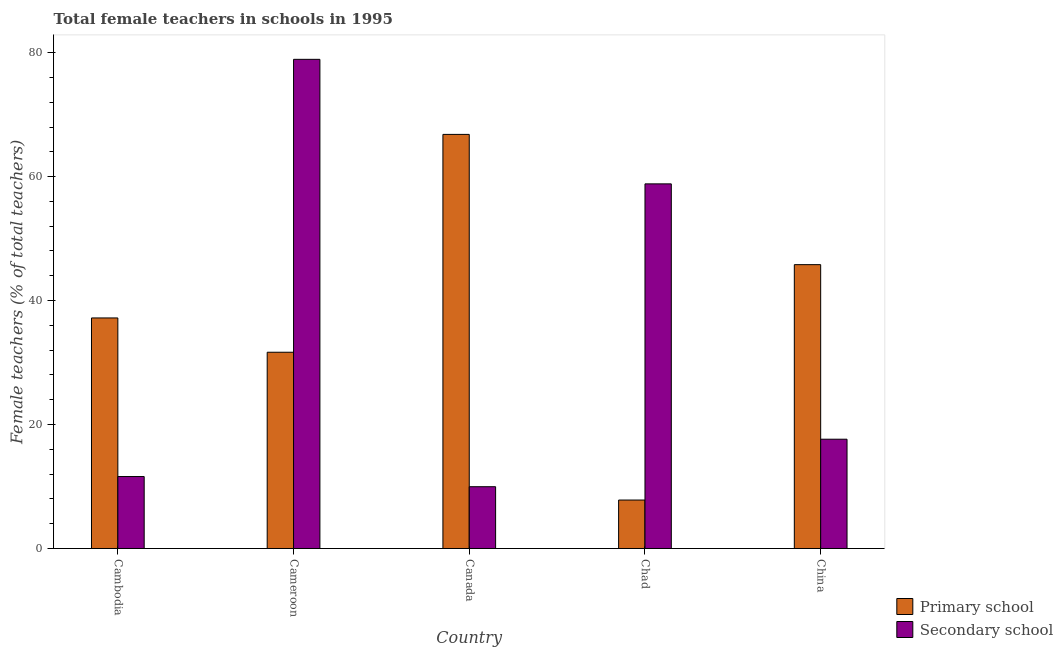How many groups of bars are there?
Offer a very short reply. 5. Are the number of bars per tick equal to the number of legend labels?
Offer a very short reply. Yes. Are the number of bars on each tick of the X-axis equal?
Make the answer very short. Yes. What is the label of the 3rd group of bars from the left?
Offer a terse response. Canada. What is the percentage of female teachers in primary schools in China?
Keep it short and to the point. 45.8. Across all countries, what is the maximum percentage of female teachers in primary schools?
Provide a short and direct response. 66.81. Across all countries, what is the minimum percentage of female teachers in secondary schools?
Make the answer very short. 9.97. In which country was the percentage of female teachers in secondary schools maximum?
Ensure brevity in your answer.  Cameroon. In which country was the percentage of female teachers in primary schools minimum?
Your answer should be compact. Chad. What is the total percentage of female teachers in secondary schools in the graph?
Make the answer very short. 176.97. What is the difference between the percentage of female teachers in primary schools in Cameroon and that in Canada?
Offer a very short reply. -35.15. What is the difference between the percentage of female teachers in secondary schools in China and the percentage of female teachers in primary schools in Cameroon?
Your response must be concise. -14.03. What is the average percentage of female teachers in primary schools per country?
Your response must be concise. 37.86. What is the difference between the percentage of female teachers in primary schools and percentage of female teachers in secondary schools in China?
Make the answer very short. 28.16. What is the ratio of the percentage of female teachers in secondary schools in Canada to that in Chad?
Your answer should be very brief. 0.17. Is the difference between the percentage of female teachers in secondary schools in Canada and China greater than the difference between the percentage of female teachers in primary schools in Canada and China?
Provide a short and direct response. No. What is the difference between the highest and the second highest percentage of female teachers in secondary schools?
Make the answer very short. 20.09. What is the difference between the highest and the lowest percentage of female teachers in primary schools?
Keep it short and to the point. 59. Is the sum of the percentage of female teachers in secondary schools in Cambodia and Canada greater than the maximum percentage of female teachers in primary schools across all countries?
Ensure brevity in your answer.  No. What does the 2nd bar from the left in Cameroon represents?
Provide a short and direct response. Secondary school. What does the 2nd bar from the right in Cambodia represents?
Your answer should be very brief. Primary school. How many bars are there?
Keep it short and to the point. 10. Are the values on the major ticks of Y-axis written in scientific E-notation?
Keep it short and to the point. No. Does the graph contain any zero values?
Make the answer very short. No. Where does the legend appear in the graph?
Offer a very short reply. Bottom right. How many legend labels are there?
Provide a short and direct response. 2. How are the legend labels stacked?
Your response must be concise. Vertical. What is the title of the graph?
Provide a succinct answer. Total female teachers in schools in 1995. What is the label or title of the X-axis?
Provide a succinct answer. Country. What is the label or title of the Y-axis?
Offer a very short reply. Female teachers (% of total teachers). What is the Female teachers (% of total teachers) of Primary school in Cambodia?
Ensure brevity in your answer.  37.2. What is the Female teachers (% of total teachers) in Secondary school in Cambodia?
Offer a very short reply. 11.61. What is the Female teachers (% of total teachers) in Primary school in Cameroon?
Your answer should be very brief. 31.66. What is the Female teachers (% of total teachers) in Secondary school in Cameroon?
Offer a terse response. 78.93. What is the Female teachers (% of total teachers) in Primary school in Canada?
Make the answer very short. 66.81. What is the Female teachers (% of total teachers) of Secondary school in Canada?
Provide a succinct answer. 9.97. What is the Female teachers (% of total teachers) in Primary school in Chad?
Provide a short and direct response. 7.82. What is the Female teachers (% of total teachers) in Secondary school in Chad?
Offer a terse response. 58.83. What is the Female teachers (% of total teachers) in Primary school in China?
Provide a short and direct response. 45.8. What is the Female teachers (% of total teachers) in Secondary school in China?
Keep it short and to the point. 17.63. Across all countries, what is the maximum Female teachers (% of total teachers) of Primary school?
Provide a succinct answer. 66.81. Across all countries, what is the maximum Female teachers (% of total teachers) in Secondary school?
Offer a terse response. 78.93. Across all countries, what is the minimum Female teachers (% of total teachers) in Primary school?
Provide a succinct answer. 7.82. Across all countries, what is the minimum Female teachers (% of total teachers) of Secondary school?
Your answer should be compact. 9.97. What is the total Female teachers (% of total teachers) of Primary school in the graph?
Your answer should be compact. 189.29. What is the total Female teachers (% of total teachers) in Secondary school in the graph?
Ensure brevity in your answer.  176.97. What is the difference between the Female teachers (% of total teachers) in Primary school in Cambodia and that in Cameroon?
Give a very brief answer. 5.53. What is the difference between the Female teachers (% of total teachers) of Secondary school in Cambodia and that in Cameroon?
Provide a succinct answer. -67.32. What is the difference between the Female teachers (% of total teachers) in Primary school in Cambodia and that in Canada?
Keep it short and to the point. -29.62. What is the difference between the Female teachers (% of total teachers) in Secondary school in Cambodia and that in Canada?
Provide a short and direct response. 1.64. What is the difference between the Female teachers (% of total teachers) in Primary school in Cambodia and that in Chad?
Provide a succinct answer. 29.38. What is the difference between the Female teachers (% of total teachers) in Secondary school in Cambodia and that in Chad?
Offer a terse response. -47.22. What is the difference between the Female teachers (% of total teachers) of Primary school in Cambodia and that in China?
Make the answer very short. -8.6. What is the difference between the Female teachers (% of total teachers) in Secondary school in Cambodia and that in China?
Make the answer very short. -6.02. What is the difference between the Female teachers (% of total teachers) of Primary school in Cameroon and that in Canada?
Offer a terse response. -35.15. What is the difference between the Female teachers (% of total teachers) of Secondary school in Cameroon and that in Canada?
Offer a terse response. 68.96. What is the difference between the Female teachers (% of total teachers) in Primary school in Cameroon and that in Chad?
Provide a short and direct response. 23.85. What is the difference between the Female teachers (% of total teachers) in Secondary school in Cameroon and that in Chad?
Offer a very short reply. 20.09. What is the difference between the Female teachers (% of total teachers) in Primary school in Cameroon and that in China?
Offer a terse response. -14.13. What is the difference between the Female teachers (% of total teachers) in Secondary school in Cameroon and that in China?
Your answer should be compact. 61.29. What is the difference between the Female teachers (% of total teachers) of Primary school in Canada and that in Chad?
Keep it short and to the point. 59. What is the difference between the Female teachers (% of total teachers) of Secondary school in Canada and that in Chad?
Give a very brief answer. -48.86. What is the difference between the Female teachers (% of total teachers) in Primary school in Canada and that in China?
Give a very brief answer. 21.02. What is the difference between the Female teachers (% of total teachers) of Secondary school in Canada and that in China?
Provide a succinct answer. -7.66. What is the difference between the Female teachers (% of total teachers) of Primary school in Chad and that in China?
Offer a terse response. -37.98. What is the difference between the Female teachers (% of total teachers) of Secondary school in Chad and that in China?
Keep it short and to the point. 41.2. What is the difference between the Female teachers (% of total teachers) in Primary school in Cambodia and the Female teachers (% of total teachers) in Secondary school in Cameroon?
Keep it short and to the point. -41.73. What is the difference between the Female teachers (% of total teachers) in Primary school in Cambodia and the Female teachers (% of total teachers) in Secondary school in Canada?
Make the answer very short. 27.23. What is the difference between the Female teachers (% of total teachers) of Primary school in Cambodia and the Female teachers (% of total teachers) of Secondary school in Chad?
Provide a succinct answer. -21.63. What is the difference between the Female teachers (% of total teachers) of Primary school in Cambodia and the Female teachers (% of total teachers) of Secondary school in China?
Your answer should be compact. 19.57. What is the difference between the Female teachers (% of total teachers) in Primary school in Cameroon and the Female teachers (% of total teachers) in Secondary school in Canada?
Keep it short and to the point. 21.7. What is the difference between the Female teachers (% of total teachers) in Primary school in Cameroon and the Female teachers (% of total teachers) in Secondary school in Chad?
Your answer should be very brief. -27.17. What is the difference between the Female teachers (% of total teachers) in Primary school in Cameroon and the Female teachers (% of total teachers) in Secondary school in China?
Ensure brevity in your answer.  14.03. What is the difference between the Female teachers (% of total teachers) in Primary school in Canada and the Female teachers (% of total teachers) in Secondary school in Chad?
Give a very brief answer. 7.98. What is the difference between the Female teachers (% of total teachers) in Primary school in Canada and the Female teachers (% of total teachers) in Secondary school in China?
Give a very brief answer. 49.18. What is the difference between the Female teachers (% of total teachers) of Primary school in Chad and the Female teachers (% of total teachers) of Secondary school in China?
Offer a terse response. -9.81. What is the average Female teachers (% of total teachers) in Primary school per country?
Offer a very short reply. 37.86. What is the average Female teachers (% of total teachers) in Secondary school per country?
Provide a short and direct response. 35.39. What is the difference between the Female teachers (% of total teachers) in Primary school and Female teachers (% of total teachers) in Secondary school in Cambodia?
Your response must be concise. 25.59. What is the difference between the Female teachers (% of total teachers) in Primary school and Female teachers (% of total teachers) in Secondary school in Cameroon?
Offer a very short reply. -47.26. What is the difference between the Female teachers (% of total teachers) of Primary school and Female teachers (% of total teachers) of Secondary school in Canada?
Give a very brief answer. 56.85. What is the difference between the Female teachers (% of total teachers) in Primary school and Female teachers (% of total teachers) in Secondary school in Chad?
Provide a short and direct response. -51.01. What is the difference between the Female teachers (% of total teachers) of Primary school and Female teachers (% of total teachers) of Secondary school in China?
Offer a terse response. 28.16. What is the ratio of the Female teachers (% of total teachers) in Primary school in Cambodia to that in Cameroon?
Ensure brevity in your answer.  1.17. What is the ratio of the Female teachers (% of total teachers) of Secondary school in Cambodia to that in Cameroon?
Provide a succinct answer. 0.15. What is the ratio of the Female teachers (% of total teachers) in Primary school in Cambodia to that in Canada?
Your answer should be very brief. 0.56. What is the ratio of the Female teachers (% of total teachers) of Secondary school in Cambodia to that in Canada?
Give a very brief answer. 1.16. What is the ratio of the Female teachers (% of total teachers) in Primary school in Cambodia to that in Chad?
Provide a succinct answer. 4.76. What is the ratio of the Female teachers (% of total teachers) of Secondary school in Cambodia to that in Chad?
Give a very brief answer. 0.2. What is the ratio of the Female teachers (% of total teachers) in Primary school in Cambodia to that in China?
Give a very brief answer. 0.81. What is the ratio of the Female teachers (% of total teachers) of Secondary school in Cambodia to that in China?
Provide a succinct answer. 0.66. What is the ratio of the Female teachers (% of total teachers) in Primary school in Cameroon to that in Canada?
Keep it short and to the point. 0.47. What is the ratio of the Female teachers (% of total teachers) in Secondary school in Cameroon to that in Canada?
Give a very brief answer. 7.92. What is the ratio of the Female teachers (% of total teachers) of Primary school in Cameroon to that in Chad?
Your response must be concise. 4.05. What is the ratio of the Female teachers (% of total teachers) in Secondary school in Cameroon to that in Chad?
Provide a succinct answer. 1.34. What is the ratio of the Female teachers (% of total teachers) of Primary school in Cameroon to that in China?
Keep it short and to the point. 0.69. What is the ratio of the Female teachers (% of total teachers) of Secondary school in Cameroon to that in China?
Ensure brevity in your answer.  4.48. What is the ratio of the Female teachers (% of total teachers) in Primary school in Canada to that in Chad?
Provide a succinct answer. 8.55. What is the ratio of the Female teachers (% of total teachers) of Secondary school in Canada to that in Chad?
Your response must be concise. 0.17. What is the ratio of the Female teachers (% of total teachers) of Primary school in Canada to that in China?
Offer a very short reply. 1.46. What is the ratio of the Female teachers (% of total teachers) in Secondary school in Canada to that in China?
Provide a short and direct response. 0.57. What is the ratio of the Female teachers (% of total teachers) in Primary school in Chad to that in China?
Your response must be concise. 0.17. What is the ratio of the Female teachers (% of total teachers) in Secondary school in Chad to that in China?
Give a very brief answer. 3.34. What is the difference between the highest and the second highest Female teachers (% of total teachers) in Primary school?
Offer a terse response. 21.02. What is the difference between the highest and the second highest Female teachers (% of total teachers) of Secondary school?
Make the answer very short. 20.09. What is the difference between the highest and the lowest Female teachers (% of total teachers) of Primary school?
Your answer should be compact. 59. What is the difference between the highest and the lowest Female teachers (% of total teachers) in Secondary school?
Offer a terse response. 68.96. 